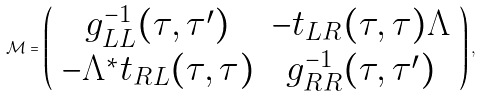Convert formula to latex. <formula><loc_0><loc_0><loc_500><loc_500>\mathcal { M } = \left ( \begin{array} { c c } g _ { L L } ^ { - 1 } ( \tau , \tau ^ { \prime } ) & - t _ { L R } ( \tau , \tau ) \Lambda \\ - \Lambda ^ { * } t _ { R L } ( \tau , \tau ) & g _ { R R } ^ { - 1 } ( \tau , \tau ^ { \prime } ) \end{array} \right ) ,</formula> 